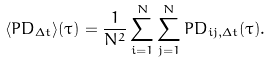Convert formula to latex. <formula><loc_0><loc_0><loc_500><loc_500>\langle P D _ { \Delta t } \rangle ( \tau ) = \frac { 1 } { N ^ { 2 } } \sum _ { i = 1 } ^ { N } \sum _ { j = 1 } ^ { N } P D _ { i j , \Delta t } ( \tau ) .</formula> 